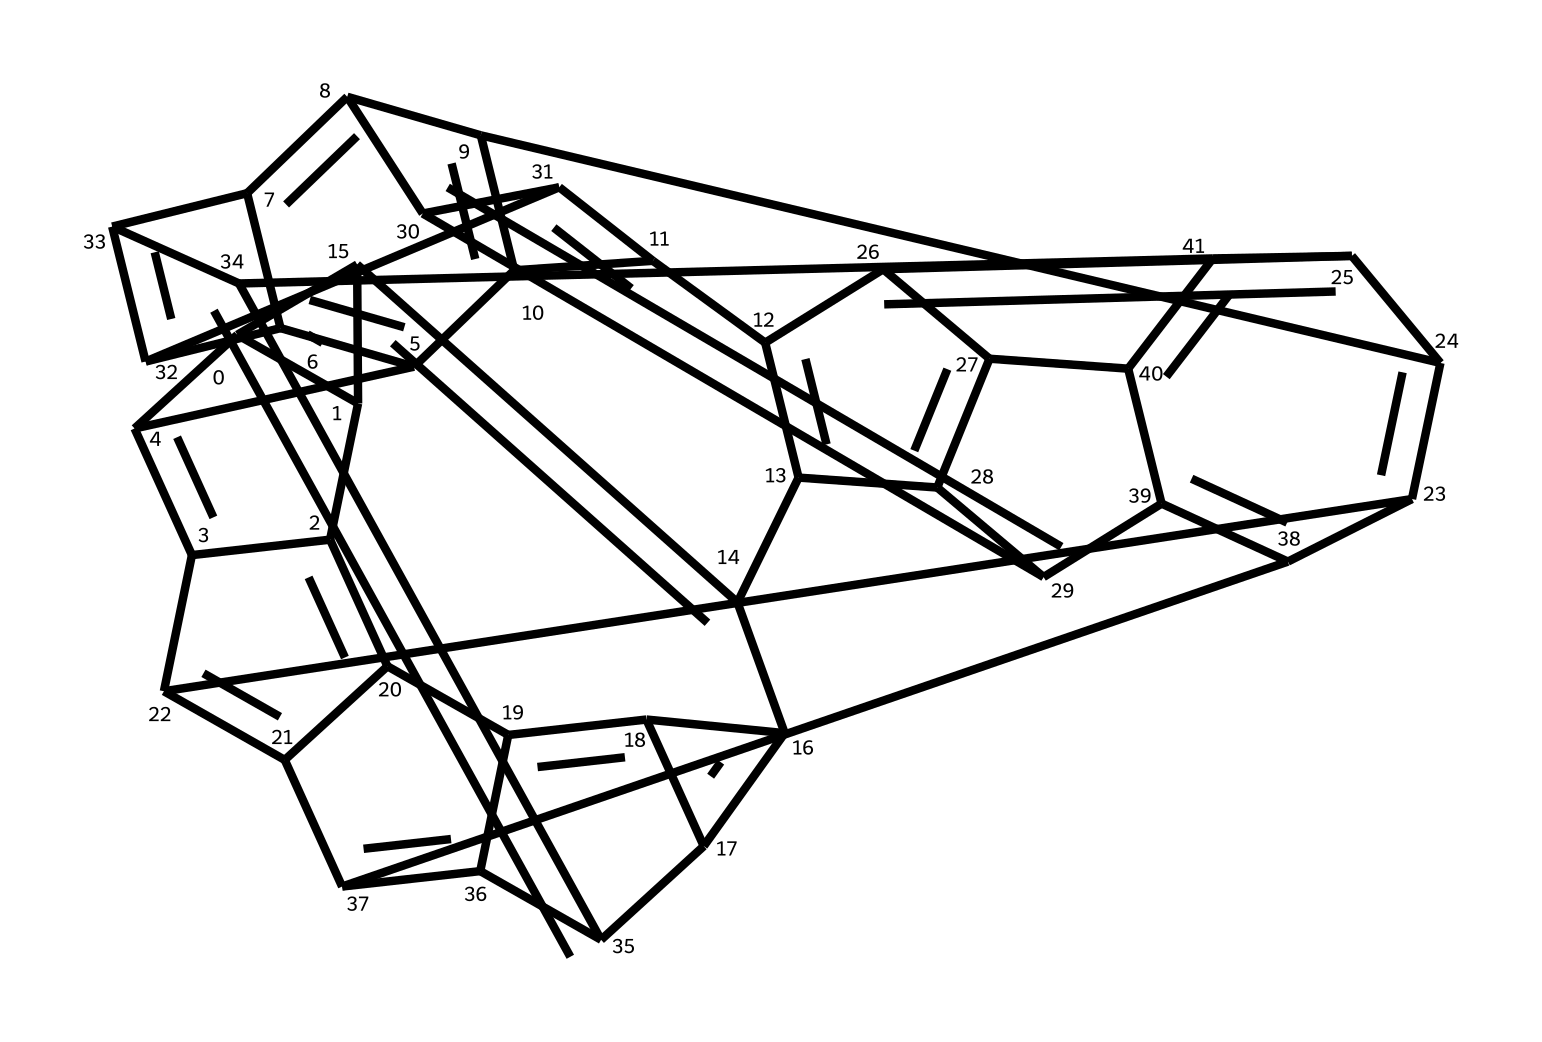What type of structure does this chemical represent? The visual representation reveals a spherical structure typical of fullerenes. Fullerenes are known for their hollow, cage-like geometric forms that can resemble soccer balls or other intricate configurations.
Answer: fullerene How many carbon atoms are present in this fullerene? By analyzing the SMILES representation, we count the number of carbon atoms. The first part of the chemical shows multiple interconnected carbon atoms, and through careful observation, we determine that there are 60 carbon atoms in total.
Answer: 60 What characteristic property does the presence of fullerenes confer to carbon fiber composites? Fullerenes can improve the tensile strength and durability of carbon fiber composites. Their unique arrangement allows them to enhance the mechanical properties by distributing stress more evenly across the composite.
Answer: increased strength What is the molecular formula for this fullerene? Given the carbon count from earlier and its structure type, we derive the molecular formula. Since it's purely composed of carbon atoms, we represent this as C60.
Answer: C60 Is this compound soluble in water or organic solvents? Fullerenes, including the one represented by the given SMILES, are typically not soluble in water but do dissolve in organic solvents. This property is due to their hydrophobic nature resulting from their carbon-based structure.
Answer: organic solvents What effect do fullerenes have on the sound quality of guitar bodies when used in composites? The incorporation of fullerenes into guitar bodies can enhance the acoustic properties, potentially leading to better sound resonance and projection. This is attributed to the composite's improved mechanical characteristics, which may affect sound transmission.
Answer: improved resonance 